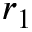<formula> <loc_0><loc_0><loc_500><loc_500>r _ { 1 }</formula> 